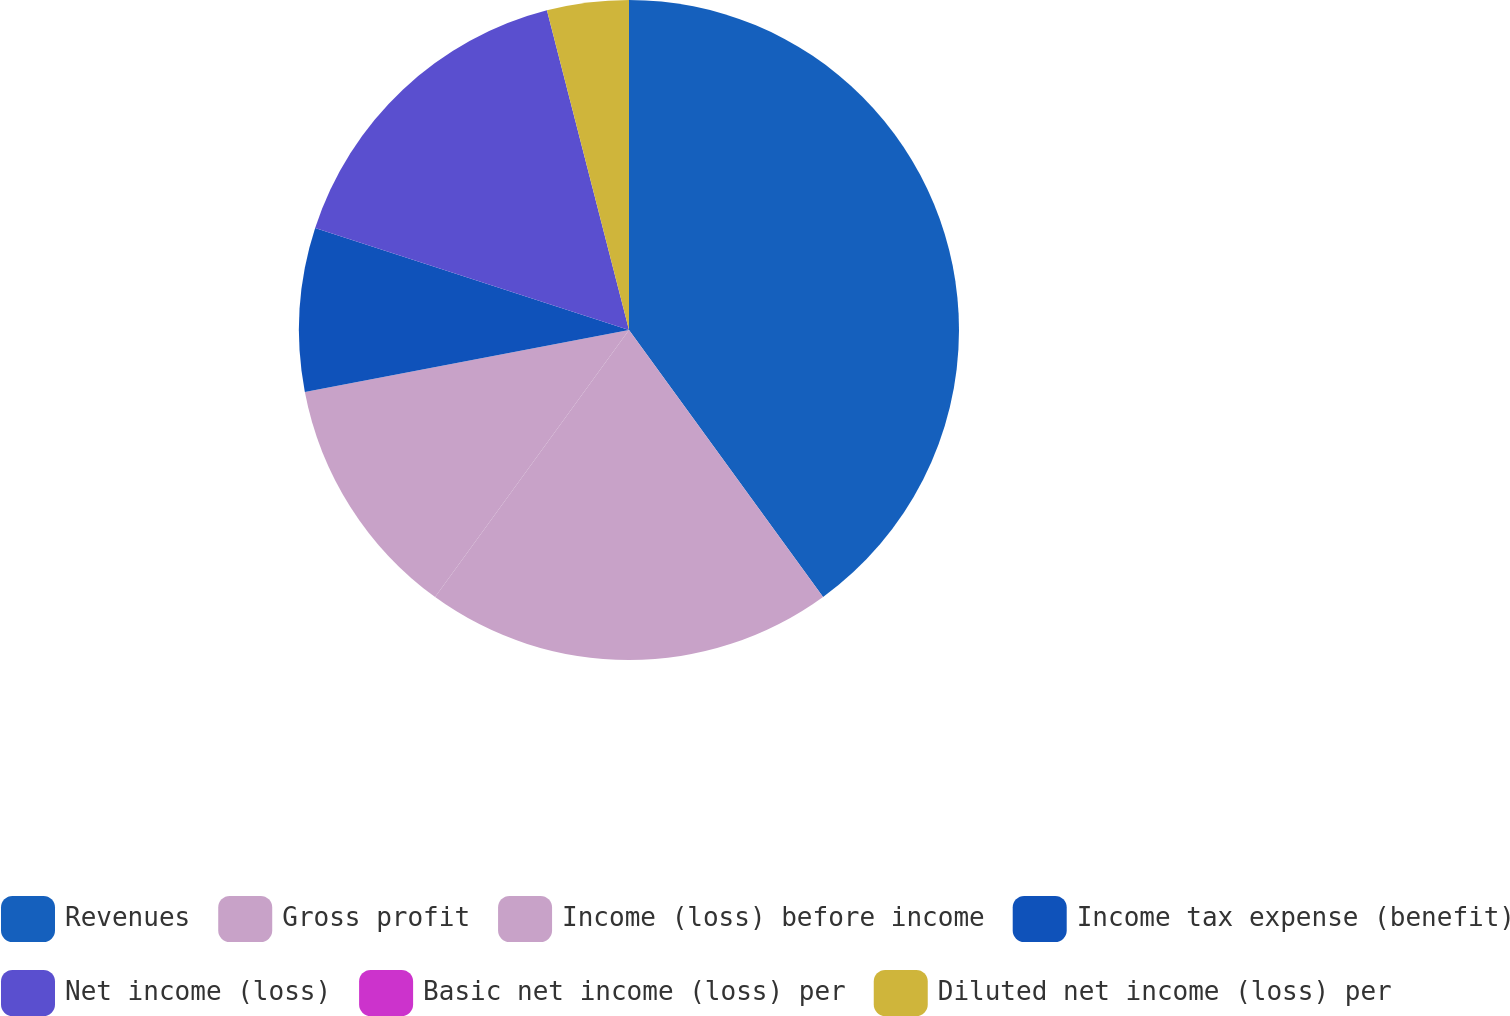<chart> <loc_0><loc_0><loc_500><loc_500><pie_chart><fcel>Revenues<fcel>Gross profit<fcel>Income (loss) before income<fcel>Income tax expense (benefit)<fcel>Net income (loss)<fcel>Basic net income (loss) per<fcel>Diluted net income (loss) per<nl><fcel>39.99%<fcel>20.0%<fcel>12.0%<fcel>8.0%<fcel>16.0%<fcel>0.0%<fcel>4.0%<nl></chart> 